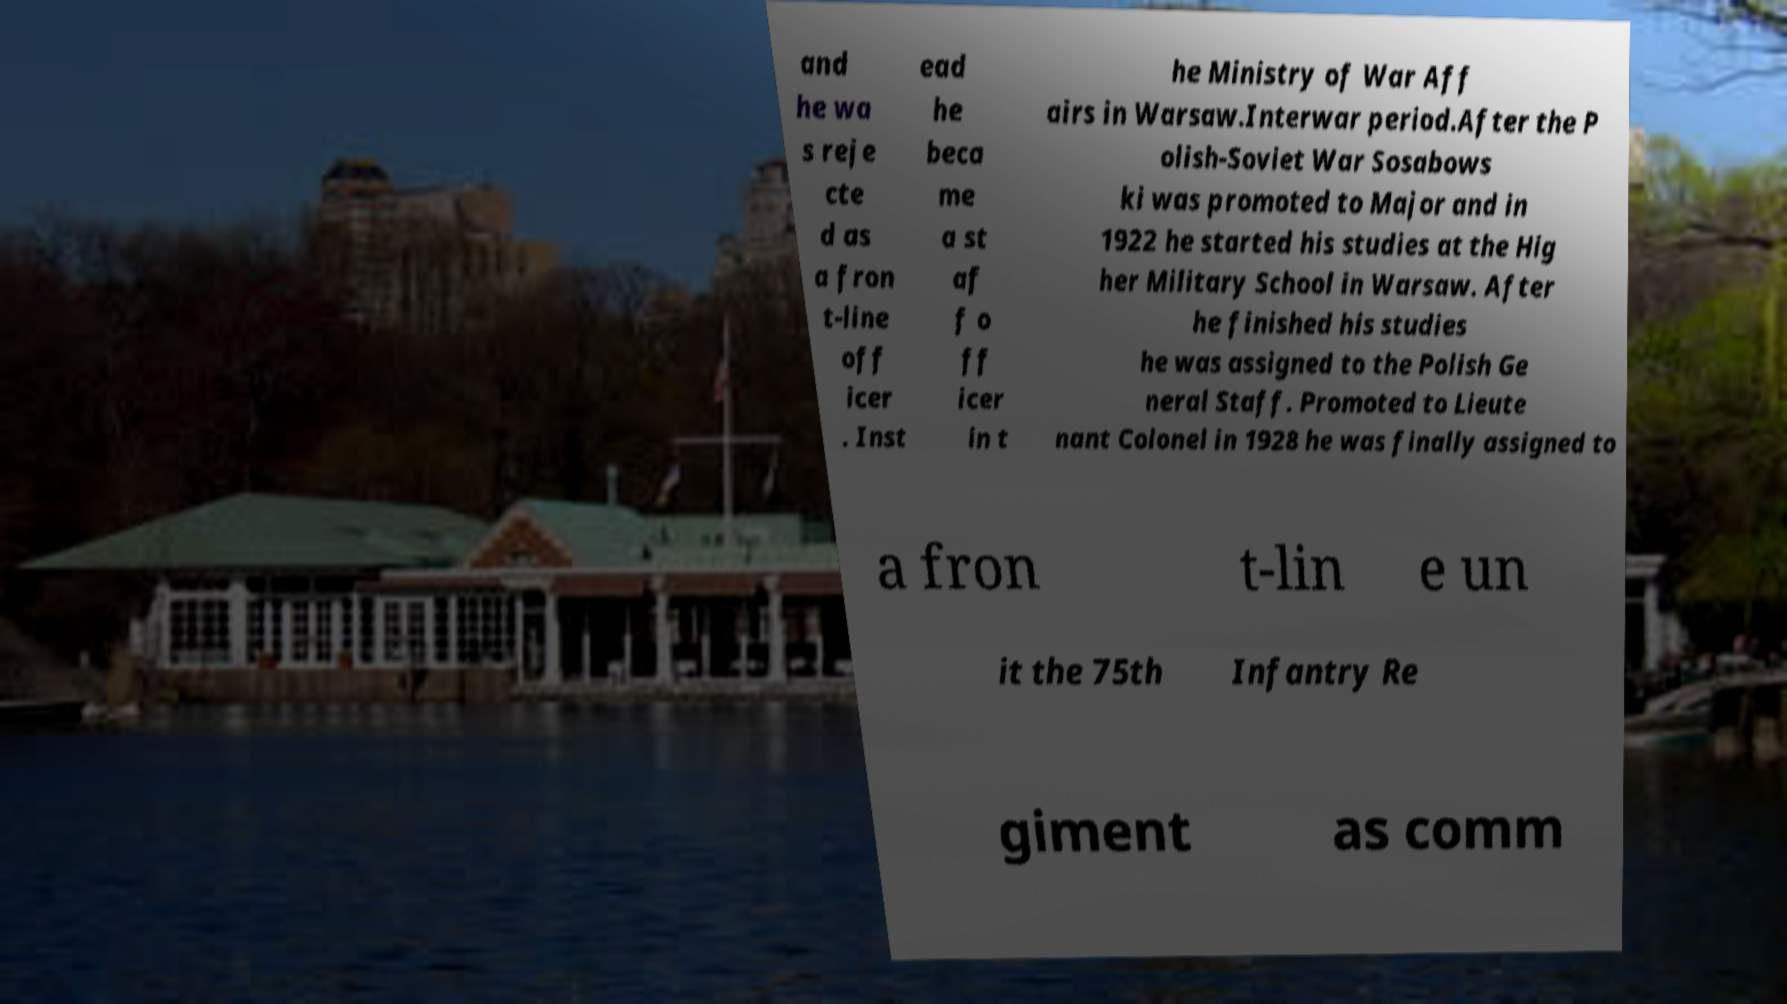What messages or text are displayed in this image? I need them in a readable, typed format. and he wa s reje cte d as a fron t-line off icer . Inst ead he beca me a st af f o ff icer in t he Ministry of War Aff airs in Warsaw.Interwar period.After the P olish-Soviet War Sosabows ki was promoted to Major and in 1922 he started his studies at the Hig her Military School in Warsaw. After he finished his studies he was assigned to the Polish Ge neral Staff. Promoted to Lieute nant Colonel in 1928 he was finally assigned to a fron t-lin e un it the 75th Infantry Re giment as comm 